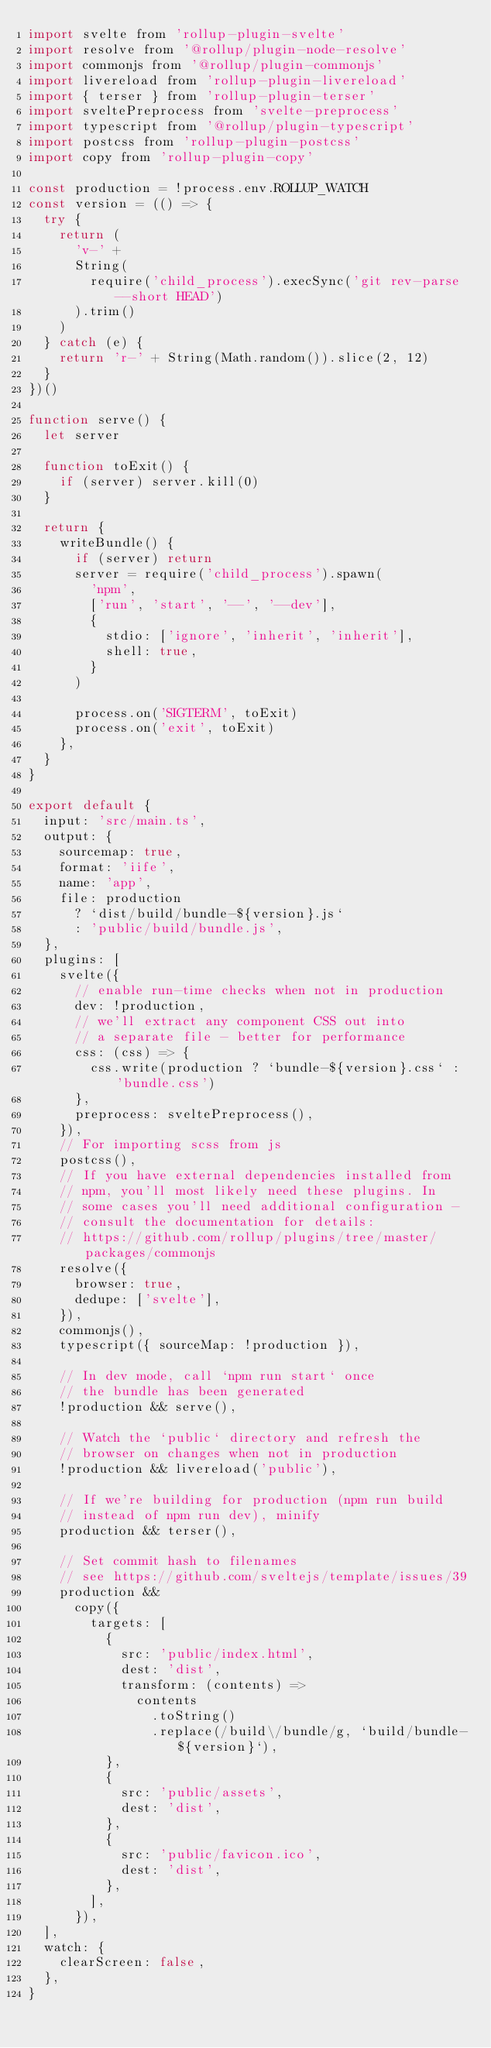<code> <loc_0><loc_0><loc_500><loc_500><_JavaScript_>import svelte from 'rollup-plugin-svelte'
import resolve from '@rollup/plugin-node-resolve'
import commonjs from '@rollup/plugin-commonjs'
import livereload from 'rollup-plugin-livereload'
import { terser } from 'rollup-plugin-terser'
import sveltePreprocess from 'svelte-preprocess'
import typescript from '@rollup/plugin-typescript'
import postcss from 'rollup-plugin-postcss'
import copy from 'rollup-plugin-copy'

const production = !process.env.ROLLUP_WATCH
const version = (() => {
  try {
    return (
      'v-' +
      String(
        require('child_process').execSync('git rev-parse --short HEAD')
      ).trim()
    )
  } catch (e) {
    return 'r-' + String(Math.random()).slice(2, 12)
  }
})()

function serve() {
  let server

  function toExit() {
    if (server) server.kill(0)
  }

  return {
    writeBundle() {
      if (server) return
      server = require('child_process').spawn(
        'npm',
        ['run', 'start', '--', '--dev'],
        {
          stdio: ['ignore', 'inherit', 'inherit'],
          shell: true,
        }
      )

      process.on('SIGTERM', toExit)
      process.on('exit', toExit)
    },
  }
}

export default {
  input: 'src/main.ts',
  output: {
    sourcemap: true,
    format: 'iife',
    name: 'app',
    file: production
      ? `dist/build/bundle-${version}.js`
      : 'public/build/bundle.js',
  },
  plugins: [
    svelte({
      // enable run-time checks when not in production
      dev: !production,
      // we'll extract any component CSS out into
      // a separate file - better for performance
      css: (css) => {
        css.write(production ? `bundle-${version}.css` : 'bundle.css')
      },
      preprocess: sveltePreprocess(),
    }),
    // For importing scss from js
    postcss(),
    // If you have external dependencies installed from
    // npm, you'll most likely need these plugins. In
    // some cases you'll need additional configuration -
    // consult the documentation for details:
    // https://github.com/rollup/plugins/tree/master/packages/commonjs
    resolve({
      browser: true,
      dedupe: ['svelte'],
    }),
    commonjs(),
    typescript({ sourceMap: !production }),

    // In dev mode, call `npm run start` once
    // the bundle has been generated
    !production && serve(),

    // Watch the `public` directory and refresh the
    // browser on changes when not in production
    !production && livereload('public'),

    // If we're building for production (npm run build
    // instead of npm run dev), minify
    production && terser(),

    // Set commit hash to filenames
    // see https://github.com/sveltejs/template/issues/39
    production &&
      copy({
        targets: [
          {
            src: 'public/index.html',
            dest: 'dist',
            transform: (contents) =>
              contents
                .toString()
                .replace(/build\/bundle/g, `build/bundle-${version}`),
          },
          {
            src: 'public/assets',
            dest: 'dist',
          },
          {
            src: 'public/favicon.ico',
            dest: 'dist',
          },
        ],
      }),
  ],
  watch: {
    clearScreen: false,
  },
}
</code> 